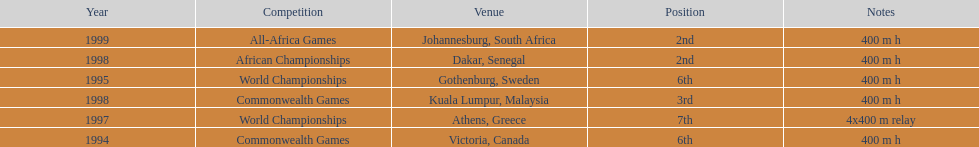How long was the relay at the 1997 world championships that ken harden ran 4x400 m relay. 